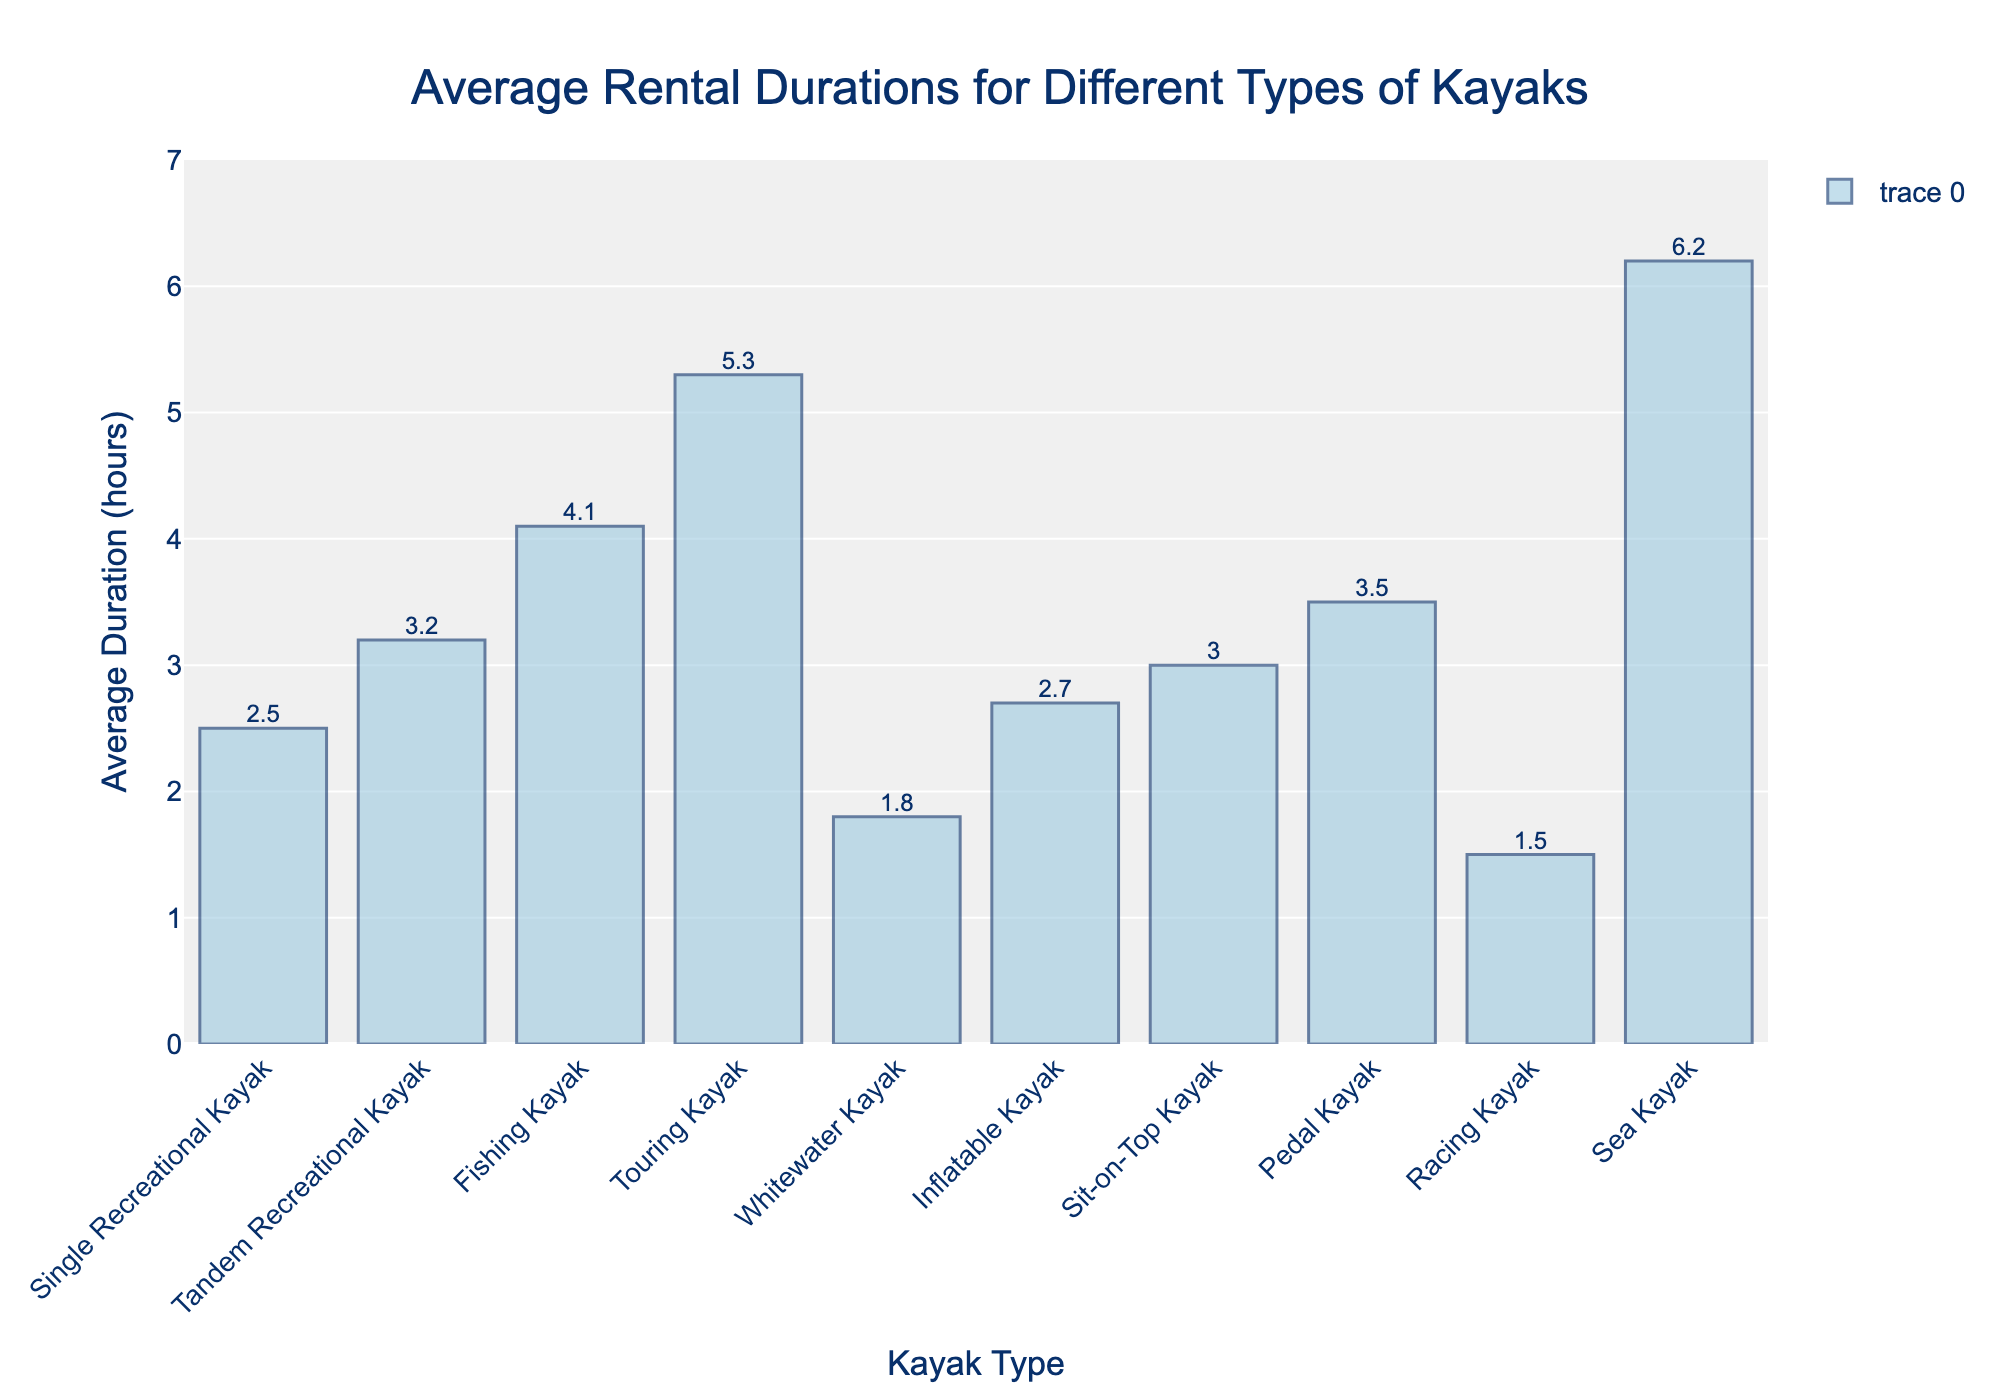What's the type of kayak with the highest average rental duration? The bar chart shows the average rental duration for each type of kayak. The sea kayak has the tallest bar, indicating the highest average rental duration.
Answer: Sea Kayak Which type of kayak has an average rental duration of 1.8 hours? By looking at the y-axis and matching it with the corresponding bar, the whitewater kayak is the one with an average rental duration of 1.8 hours.
Answer: Whitewater Kayak How much longer is the average rental duration of a sea kayak compared to a racing kayak? Identify the average rental durations of the sea kayak (6.2 hours) and the racing kayak (1.5 hours) and subtract: 6.2 - 1.5 = 4.7 hours.
Answer: 4.7 hours Which kayak types have average rental durations between 2 and 3 hours? The bars between 2 and 3 hours correspond to the single recreational kayak (2.5 hours), inflatable kayak (2.7 hours), and sit-on-top kayak (3.0 hours).
Answer: Single Recreational Kayak, Inflatable Kayak, Sit-on-Top Kayak What's the total average rental duration for tandem recreational kayaks and pedal kayaks combined? Add the average rental durations of tandem recreational kayaks (3.2 hours) and pedal kayaks (3.5 hours): 3.2 + 3.5 = 6.7 hours.
Answer: 6.7 hours Is the average rental duration for fishing kayaks greater than that of sit-on-top kayaks? By comparing the average rental durations, the fishing kayak (4.1 hours) has a longer duration than the sit-on-top kayak (3.0 hours).
Answer: Yes What is the difference in average rental duration between the touring kayak and the single recreational kayak? Subtract the average rental duration of the single recreational kayak (2.5 hours) from the touring kayak (5.3 hours): 5.3 - 2.5 = 2.8 hours.
Answer: 2.8 hours How many kayak types have average rental durations of 3 hours or more? By counting the bars that reach or exceed the 3-hour mark, there are 5 types: tandem recreational kayak, fishing kayak, touring kayak, pedal kayak, and sea kayak.
Answer: 5 If you combine the average rental durations of the top two types of recreational kayaks (single and tandem), what do you get? Adding the average rental durations of single recreational kayak (2.5 hours) and tandem recreational kayak (3.2 hours): 2.5 + 3.2 = 5.7 hours.
Answer: 5.7 hours What is the median average rental duration of the kayak types shown? First, list the average durations in ascending order: 1.5, 1.8, 2.5, 2.7, 3.0, 3.2, 3.5, 4.1, 5.3, 6.2. The middle two values are 3.0 and 3.2, so the median is (3.0 + 3.2) / 2 = 3.1 hours.
Answer: 3.1 hours 